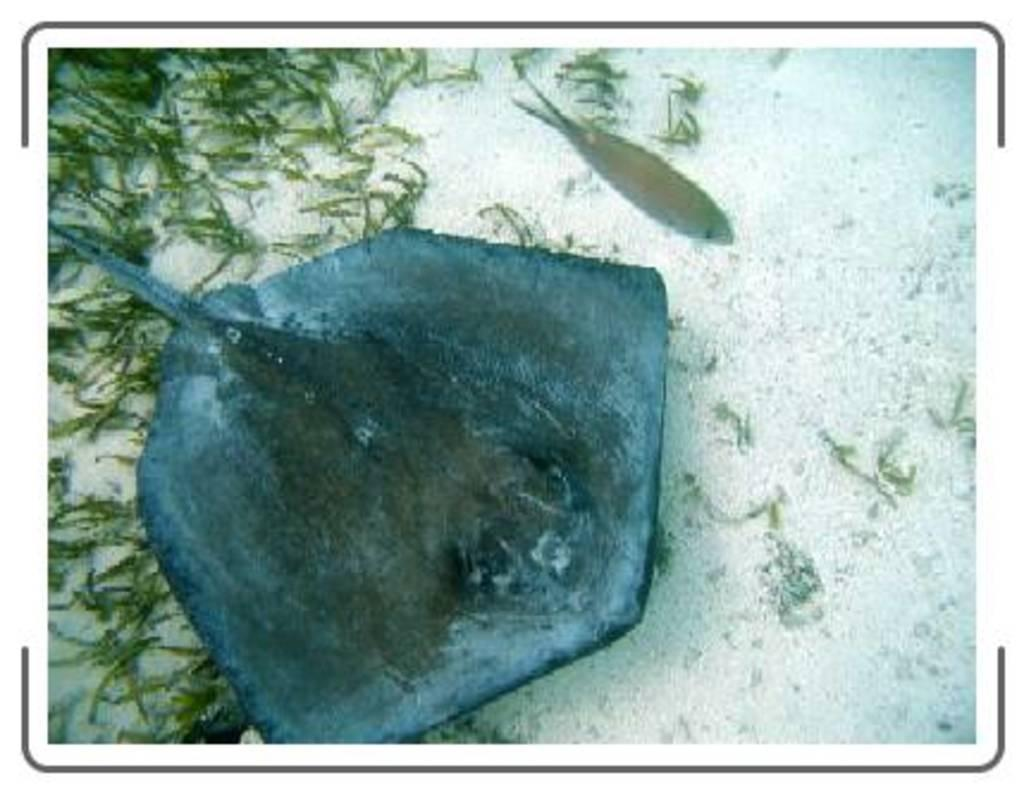What is the primary element in the image? There is water in the image. What type of creature can be seen in the water? There is a fish in the water. What other type of creature can be seen in the water? There is a water animal in the water. What can be seen in the image besides the water? There is grass visible in the image. What type of health advice can be seen in the image? There is no health advice present in the image; it features water, a fish, a water animal, and grass. How many feet are visible in the image? There are no feet visible in the image; it is a scene of water, a fish, a water animal, and grass. 